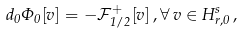Convert formula to latex. <formula><loc_0><loc_0><loc_500><loc_500>d _ { 0 } \Phi _ { 0 } [ v ] = - \mathcal { F } _ { 1 / 2 } ^ { + } [ v ] \, , \forall \, v \in H ^ { s } _ { r , 0 } \, ,</formula> 